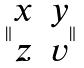Convert formula to latex. <formula><loc_0><loc_0><loc_500><loc_500>\| \begin{matrix} x & y \\ z & v \end{matrix} \|</formula> 